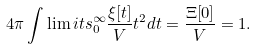<formula> <loc_0><loc_0><loc_500><loc_500>4 \pi \int \lim i t s _ { 0 } ^ { \infty } { \frac { \xi [ t ] } { V } t ^ { 2 } d t } = \frac { \Xi [ 0 ] } { V } = 1 .</formula> 